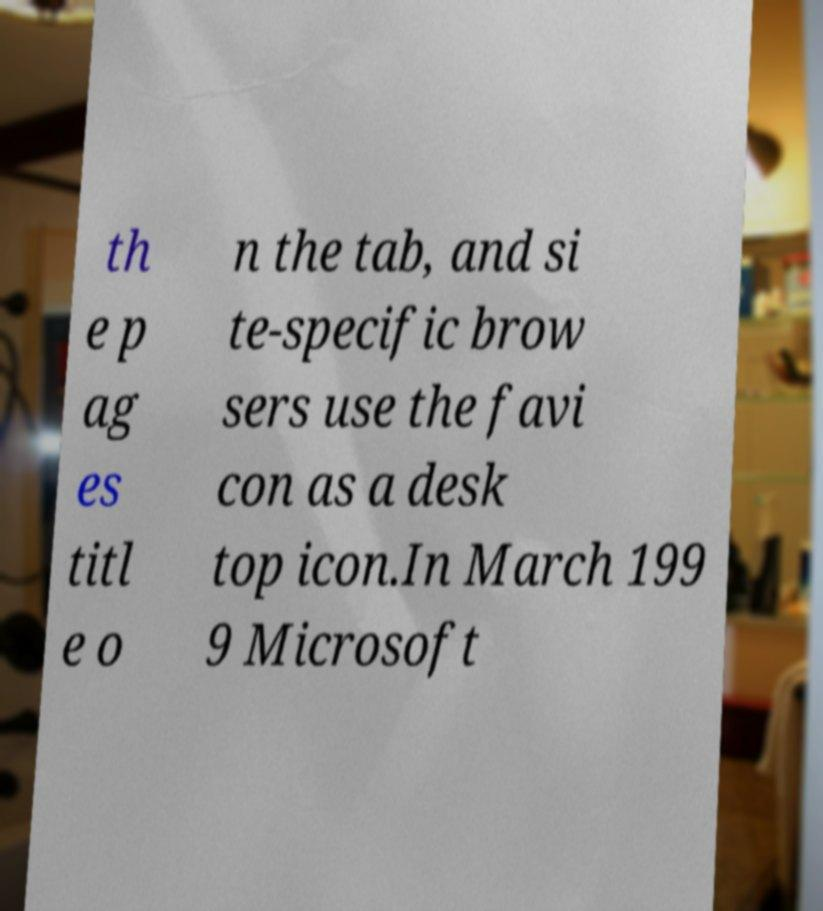Could you assist in decoding the text presented in this image and type it out clearly? th e p ag es titl e o n the tab, and si te-specific brow sers use the favi con as a desk top icon.In March 199 9 Microsoft 